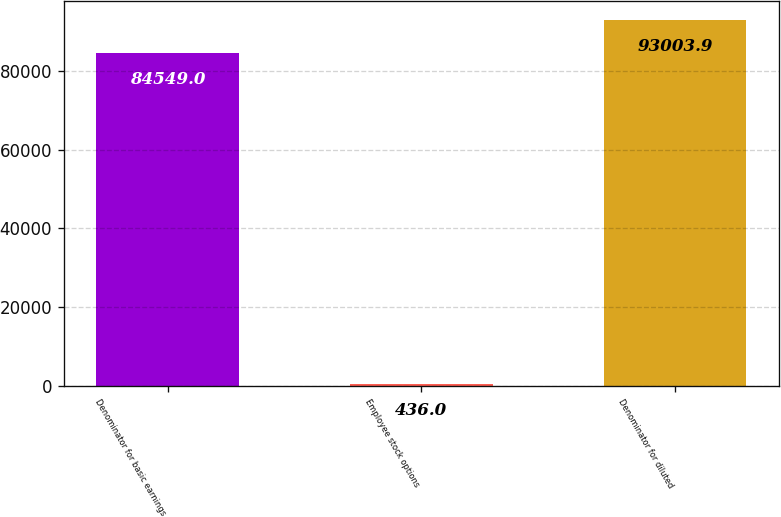<chart> <loc_0><loc_0><loc_500><loc_500><bar_chart><fcel>Denominator for basic earnings<fcel>Employee stock options<fcel>Denominator for diluted<nl><fcel>84549<fcel>436<fcel>93003.9<nl></chart> 